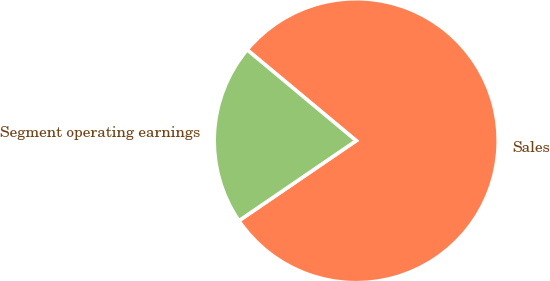Convert chart to OTSL. <chart><loc_0><loc_0><loc_500><loc_500><pie_chart><fcel>Sales<fcel>Segment operating earnings<nl><fcel>79.41%<fcel>20.59%<nl></chart> 